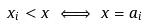<formula> <loc_0><loc_0><loc_500><loc_500>x _ { i } < x \iff x = a _ { i }</formula> 